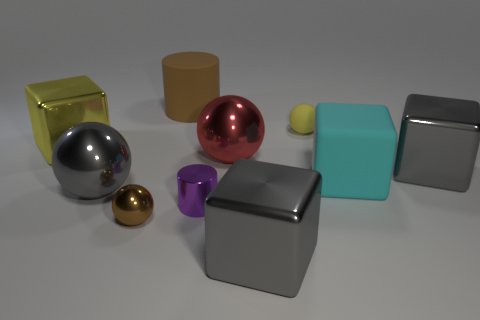Do the large brown object and the big cyan object have the same material?
Provide a succinct answer. Yes. What is the shape of the big matte object on the right side of the yellow sphere?
Give a very brief answer. Cube. Is there a yellow rubber ball that is right of the large metallic object in front of the metallic cylinder?
Offer a very short reply. Yes. Are there any cyan metallic cylinders of the same size as the purple metal cylinder?
Make the answer very short. No. There is a cylinder on the right side of the large brown rubber thing; is its color the same as the tiny metallic sphere?
Make the answer very short. No. The yellow block has what size?
Provide a succinct answer. Large. How big is the metallic cube to the left of the cylinder behind the yellow metallic block?
Ensure brevity in your answer.  Large. What number of tiny balls have the same color as the large cylinder?
Your response must be concise. 1. What number of brown matte cylinders are there?
Make the answer very short. 1. What number of small purple objects have the same material as the big brown thing?
Your answer should be very brief. 0. 